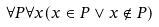Convert formula to latex. <formula><loc_0><loc_0><loc_500><loc_500>\forall P \forall x ( x \in P \vee x \notin P )</formula> 